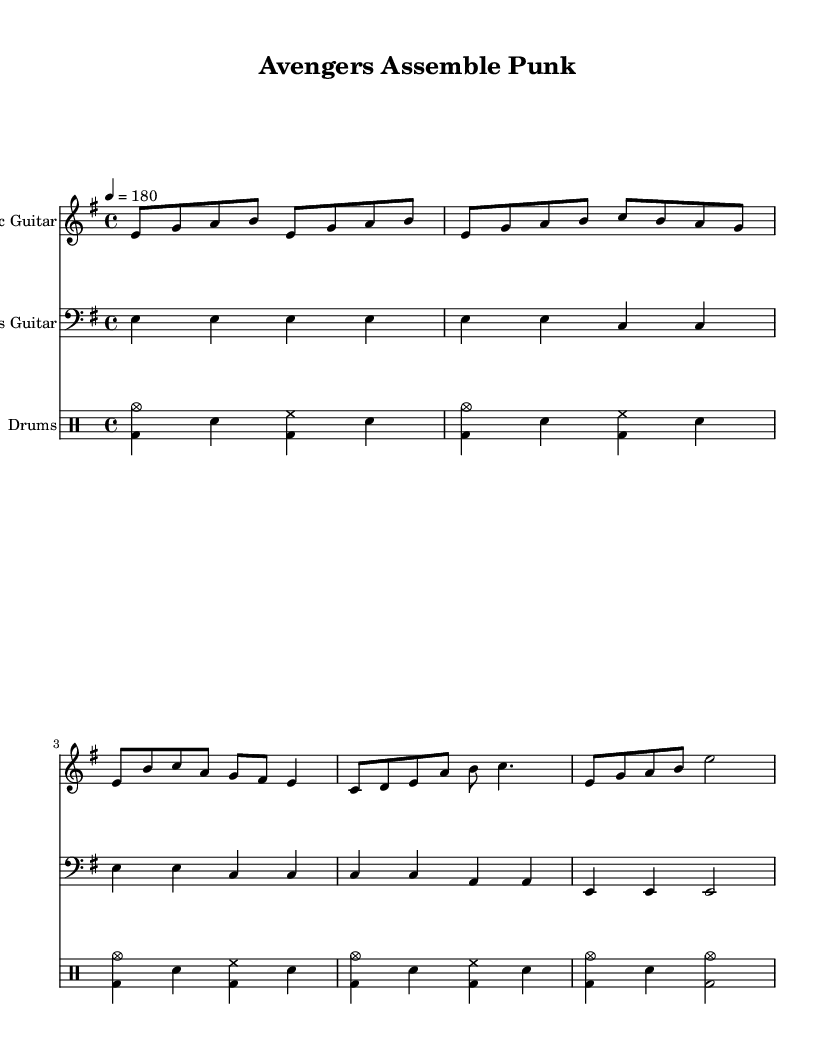what is the key signature of this music? The key signature is E minor, which has one sharp, F#. This can be identified by looking at the key signature indicated at the beginning of the score.
Answer: E minor what is the time signature of this music? The time signature is 4/4, meaning there are four beats in each measure and the quarter note gets one beat. This can be determined by examining the time signature notation located at the beginning of the score.
Answer: 4/4 what is the tempo marking of this piece? The tempo marking is quarter note equals 180, which sets the speed of the piece. This is indicated by the tempo text in the score, signaling how fast to play the notes.
Answer: quarter note equals 180 how many measures are in the electric guitar part? There are 10 measures in the electric guitar part. This can be counted by looking at the vertical bar lines which indicate the end of each measure in the notation.
Answer: 10 measures which instruments are included in this score? The instruments included are Electric Guitar, Bass Guitar, and Drums. This can be seen at the beginning of each staff section where the instrument names are specified.
Answer: Electric Guitar, Bass Guitar, Drums what kind of beat pattern does the drum part use? The drum part uses a basic punk beat with crash cymbals. This is evident by observing the rhythmic pattern in the drummode and the use of symbols that designate a punk style tempo typical for the genre.
Answer: basic punk beat with crash cymbals which section of the music is labeled as the bridge? The bridge consists of the measures starting from the note C and goes until the note C with a quarter note. This pattern can be identified in the drum and guitar parts where the rhythm shifts, distinguishing the bridge from other sections.
Answer: the section starting with C 